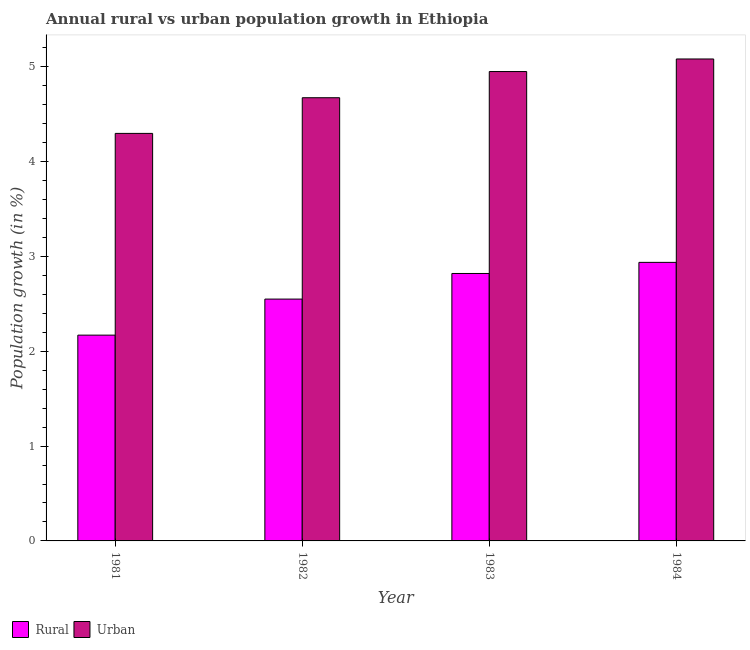How many different coloured bars are there?
Make the answer very short. 2. How many groups of bars are there?
Provide a succinct answer. 4. Are the number of bars on each tick of the X-axis equal?
Your answer should be compact. Yes. How many bars are there on the 3rd tick from the right?
Keep it short and to the point. 2. In how many cases, is the number of bars for a given year not equal to the number of legend labels?
Offer a very short reply. 0. What is the rural population growth in 1982?
Your answer should be very brief. 2.55. Across all years, what is the maximum rural population growth?
Keep it short and to the point. 2.94. Across all years, what is the minimum rural population growth?
Offer a very short reply. 2.17. In which year was the rural population growth maximum?
Provide a short and direct response. 1984. What is the total urban population growth in the graph?
Offer a very short reply. 19. What is the difference between the urban population growth in 1983 and that in 1984?
Your response must be concise. -0.13. What is the difference between the rural population growth in 1981 and the urban population growth in 1982?
Your response must be concise. -0.38. What is the average urban population growth per year?
Keep it short and to the point. 4.75. What is the ratio of the urban population growth in 1982 to that in 1983?
Keep it short and to the point. 0.94. Is the rural population growth in 1983 less than that in 1984?
Provide a succinct answer. Yes. Is the difference between the rural population growth in 1981 and 1983 greater than the difference between the urban population growth in 1981 and 1983?
Keep it short and to the point. No. What is the difference between the highest and the second highest urban population growth?
Offer a very short reply. 0.13. What is the difference between the highest and the lowest urban population growth?
Provide a short and direct response. 0.78. In how many years, is the rural population growth greater than the average rural population growth taken over all years?
Your answer should be compact. 2. Is the sum of the rural population growth in 1981 and 1984 greater than the maximum urban population growth across all years?
Your response must be concise. Yes. What does the 1st bar from the left in 1983 represents?
Keep it short and to the point. Rural. What does the 2nd bar from the right in 1983 represents?
Your answer should be very brief. Rural. How many bars are there?
Ensure brevity in your answer.  8. Are all the bars in the graph horizontal?
Offer a very short reply. No. How many years are there in the graph?
Provide a succinct answer. 4. Are the values on the major ticks of Y-axis written in scientific E-notation?
Keep it short and to the point. No. Does the graph contain grids?
Keep it short and to the point. No. How are the legend labels stacked?
Provide a short and direct response. Horizontal. What is the title of the graph?
Provide a succinct answer. Annual rural vs urban population growth in Ethiopia. Does "Lower secondary rate" appear as one of the legend labels in the graph?
Provide a short and direct response. No. What is the label or title of the Y-axis?
Offer a terse response. Population growth (in %). What is the Population growth (in %) of Rural in 1981?
Keep it short and to the point. 2.17. What is the Population growth (in %) of Urban  in 1981?
Your answer should be very brief. 4.3. What is the Population growth (in %) in Rural in 1982?
Make the answer very short. 2.55. What is the Population growth (in %) of Urban  in 1982?
Keep it short and to the point. 4.67. What is the Population growth (in %) in Rural in 1983?
Keep it short and to the point. 2.82. What is the Population growth (in %) in Urban  in 1983?
Make the answer very short. 4.95. What is the Population growth (in %) of Rural in 1984?
Give a very brief answer. 2.94. What is the Population growth (in %) in Urban  in 1984?
Ensure brevity in your answer.  5.08. Across all years, what is the maximum Population growth (in %) of Rural?
Keep it short and to the point. 2.94. Across all years, what is the maximum Population growth (in %) in Urban ?
Ensure brevity in your answer.  5.08. Across all years, what is the minimum Population growth (in %) of Rural?
Offer a very short reply. 2.17. Across all years, what is the minimum Population growth (in %) of Urban ?
Your answer should be compact. 4.3. What is the total Population growth (in %) of Rural in the graph?
Provide a succinct answer. 10.47. What is the total Population growth (in %) of Urban  in the graph?
Make the answer very short. 19. What is the difference between the Population growth (in %) in Rural in 1981 and that in 1982?
Keep it short and to the point. -0.38. What is the difference between the Population growth (in %) in Urban  in 1981 and that in 1982?
Ensure brevity in your answer.  -0.38. What is the difference between the Population growth (in %) in Rural in 1981 and that in 1983?
Your answer should be very brief. -0.65. What is the difference between the Population growth (in %) in Urban  in 1981 and that in 1983?
Your answer should be very brief. -0.65. What is the difference between the Population growth (in %) of Rural in 1981 and that in 1984?
Make the answer very short. -0.77. What is the difference between the Population growth (in %) in Urban  in 1981 and that in 1984?
Offer a very short reply. -0.78. What is the difference between the Population growth (in %) in Rural in 1982 and that in 1983?
Your answer should be very brief. -0.27. What is the difference between the Population growth (in %) in Urban  in 1982 and that in 1983?
Your response must be concise. -0.28. What is the difference between the Population growth (in %) in Rural in 1982 and that in 1984?
Make the answer very short. -0.39. What is the difference between the Population growth (in %) in Urban  in 1982 and that in 1984?
Give a very brief answer. -0.41. What is the difference between the Population growth (in %) of Rural in 1983 and that in 1984?
Provide a short and direct response. -0.12. What is the difference between the Population growth (in %) in Urban  in 1983 and that in 1984?
Make the answer very short. -0.13. What is the difference between the Population growth (in %) in Rural in 1981 and the Population growth (in %) in Urban  in 1982?
Your response must be concise. -2.5. What is the difference between the Population growth (in %) of Rural in 1981 and the Population growth (in %) of Urban  in 1983?
Provide a succinct answer. -2.78. What is the difference between the Population growth (in %) in Rural in 1981 and the Population growth (in %) in Urban  in 1984?
Your response must be concise. -2.91. What is the difference between the Population growth (in %) of Rural in 1982 and the Population growth (in %) of Urban  in 1983?
Offer a terse response. -2.4. What is the difference between the Population growth (in %) of Rural in 1982 and the Population growth (in %) of Urban  in 1984?
Provide a succinct answer. -2.53. What is the difference between the Population growth (in %) in Rural in 1983 and the Population growth (in %) in Urban  in 1984?
Give a very brief answer. -2.26. What is the average Population growth (in %) in Rural per year?
Offer a terse response. 2.62. What is the average Population growth (in %) in Urban  per year?
Offer a terse response. 4.75. In the year 1981, what is the difference between the Population growth (in %) of Rural and Population growth (in %) of Urban ?
Provide a short and direct response. -2.13. In the year 1982, what is the difference between the Population growth (in %) of Rural and Population growth (in %) of Urban ?
Offer a very short reply. -2.12. In the year 1983, what is the difference between the Population growth (in %) of Rural and Population growth (in %) of Urban ?
Offer a terse response. -2.13. In the year 1984, what is the difference between the Population growth (in %) of Rural and Population growth (in %) of Urban ?
Your answer should be compact. -2.14. What is the ratio of the Population growth (in %) in Rural in 1981 to that in 1982?
Offer a terse response. 0.85. What is the ratio of the Population growth (in %) of Urban  in 1981 to that in 1982?
Give a very brief answer. 0.92. What is the ratio of the Population growth (in %) in Rural in 1981 to that in 1983?
Provide a short and direct response. 0.77. What is the ratio of the Population growth (in %) in Urban  in 1981 to that in 1983?
Provide a succinct answer. 0.87. What is the ratio of the Population growth (in %) in Rural in 1981 to that in 1984?
Keep it short and to the point. 0.74. What is the ratio of the Population growth (in %) in Urban  in 1981 to that in 1984?
Provide a short and direct response. 0.85. What is the ratio of the Population growth (in %) of Rural in 1982 to that in 1983?
Your answer should be compact. 0.9. What is the ratio of the Population growth (in %) of Urban  in 1982 to that in 1983?
Your response must be concise. 0.94. What is the ratio of the Population growth (in %) in Rural in 1982 to that in 1984?
Your response must be concise. 0.87. What is the ratio of the Population growth (in %) in Urban  in 1982 to that in 1984?
Offer a terse response. 0.92. What is the ratio of the Population growth (in %) in Rural in 1983 to that in 1984?
Offer a terse response. 0.96. What is the ratio of the Population growth (in %) of Urban  in 1983 to that in 1984?
Your response must be concise. 0.97. What is the difference between the highest and the second highest Population growth (in %) in Rural?
Offer a terse response. 0.12. What is the difference between the highest and the second highest Population growth (in %) of Urban ?
Offer a terse response. 0.13. What is the difference between the highest and the lowest Population growth (in %) of Rural?
Ensure brevity in your answer.  0.77. What is the difference between the highest and the lowest Population growth (in %) of Urban ?
Provide a succinct answer. 0.78. 